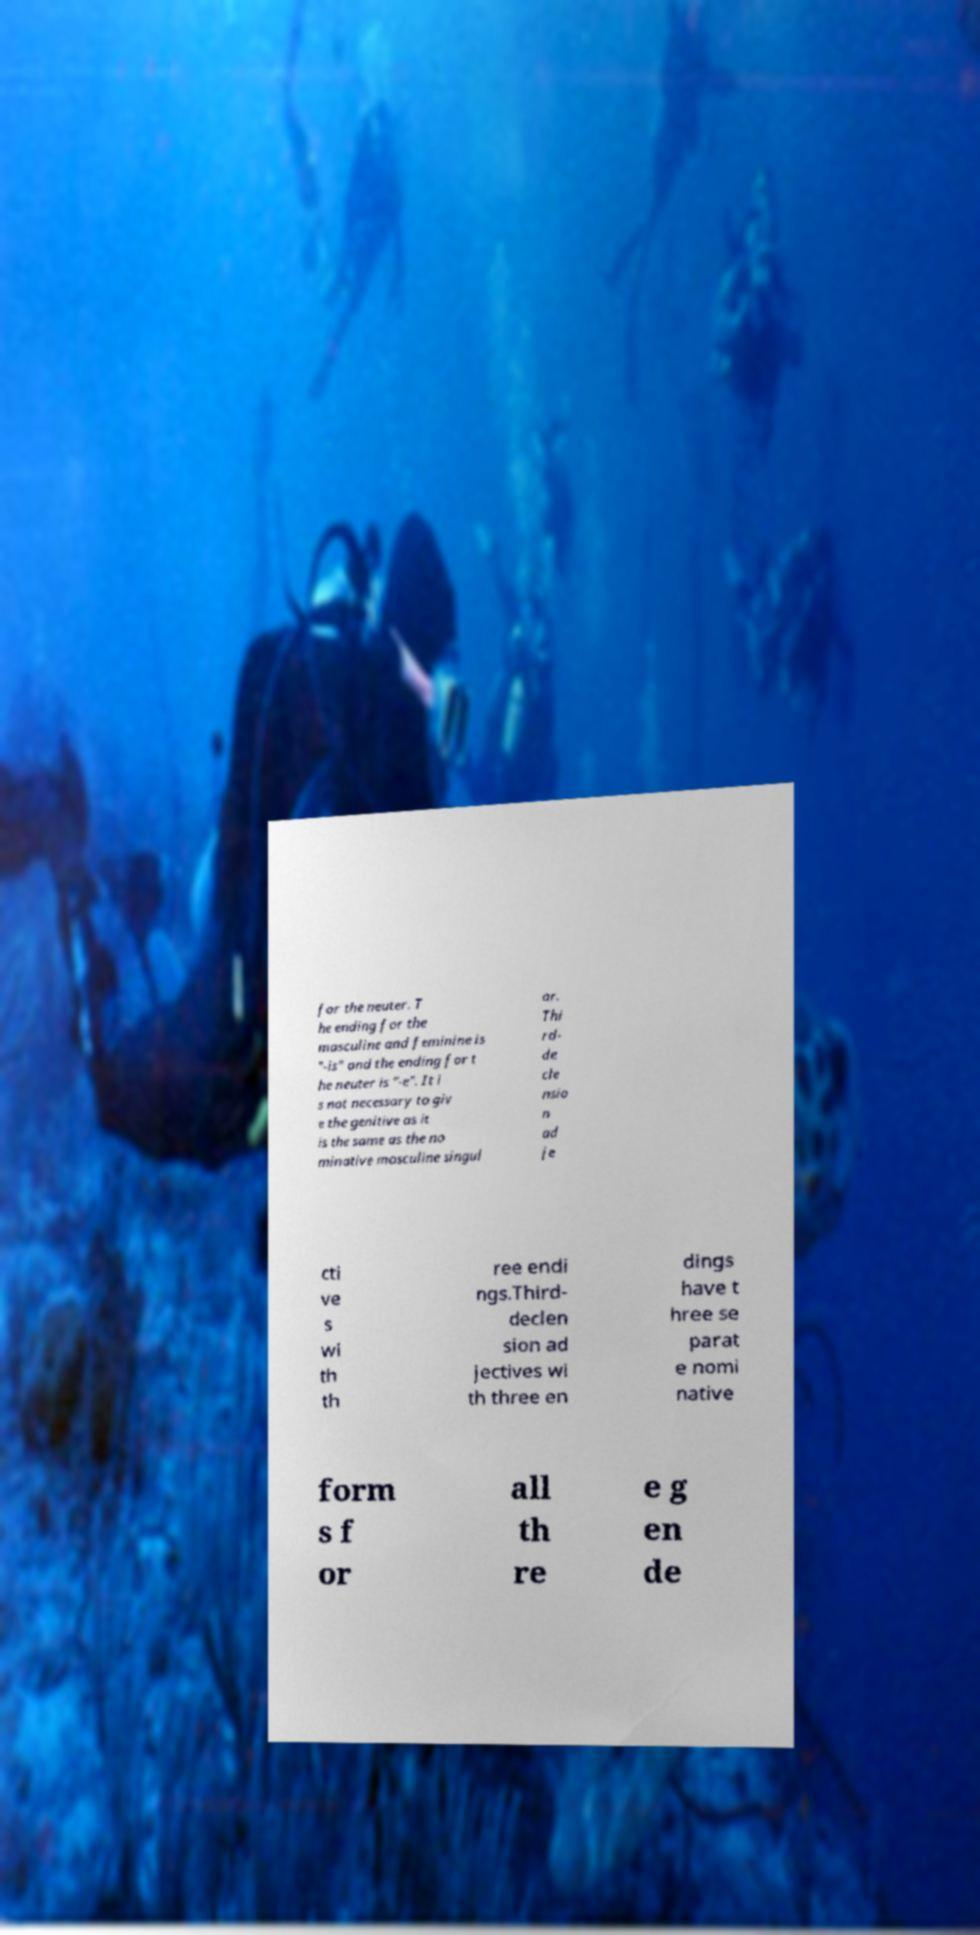For documentation purposes, I need the text within this image transcribed. Could you provide that? for the neuter. T he ending for the masculine and feminine is "-is" and the ending for t he neuter is "-e". It i s not necessary to giv e the genitive as it is the same as the no minative masculine singul ar. Thi rd- de cle nsio n ad je cti ve s wi th th ree endi ngs.Third- declen sion ad jectives wi th three en dings have t hree se parat e nomi native form s f or all th re e g en de 